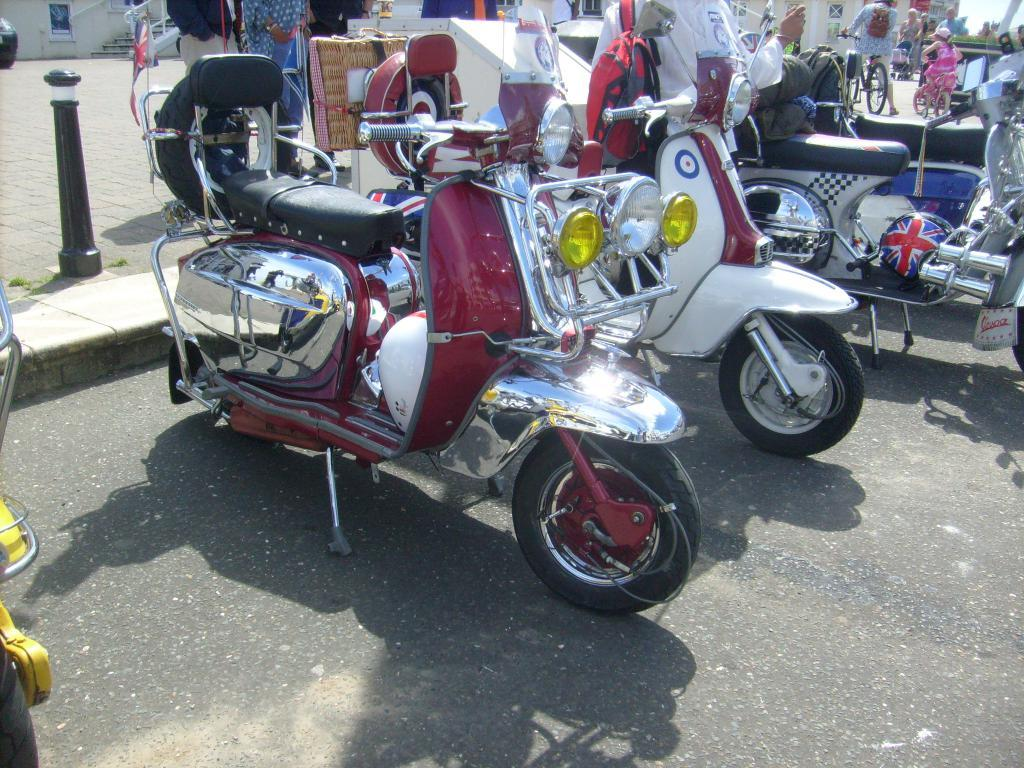What can be seen on the road in the image? There are vehicles on the road in the image. What else is visible in the background of the image? There are people visible in the background of the image. Can you describe any architectural features in the image? Yes, there are stairs in the image. Are there any friends hanging out with the bat in the wilderness in the image? There is no mention of friends, bats, or wilderness in the image; it features vehicles on the road and people in the background. 